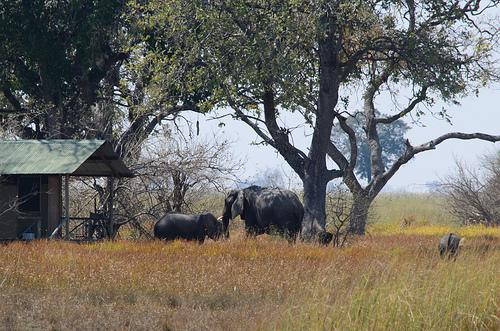Question: what are they in front of?
Choices:
A. A statue.
B. A house.
C. A gate.
D. A hot dog stand.
Answer with the letter. Answer: B Question: where are the animals standing?
Choices:
A. The barn.
B. Beside the fence.
C. In field.
D. In the shade.
Answer with the letter. Answer: C Question: how many animals are there?
Choices:
A. 7.
B. 3.
C. 8.
D. 9.
Answer with the letter. Answer: B Question: what type of animals are they?
Choices:
A. Elephants.
B. Horses.
C. Zebras.
D. Cows.
Answer with the letter. Answer: A Question: who is the mother elephant?
Choices:
A. The one on the left.
B. The one on the right.
C. The middle one.
D. The one in front.
Answer with the letter. Answer: C 